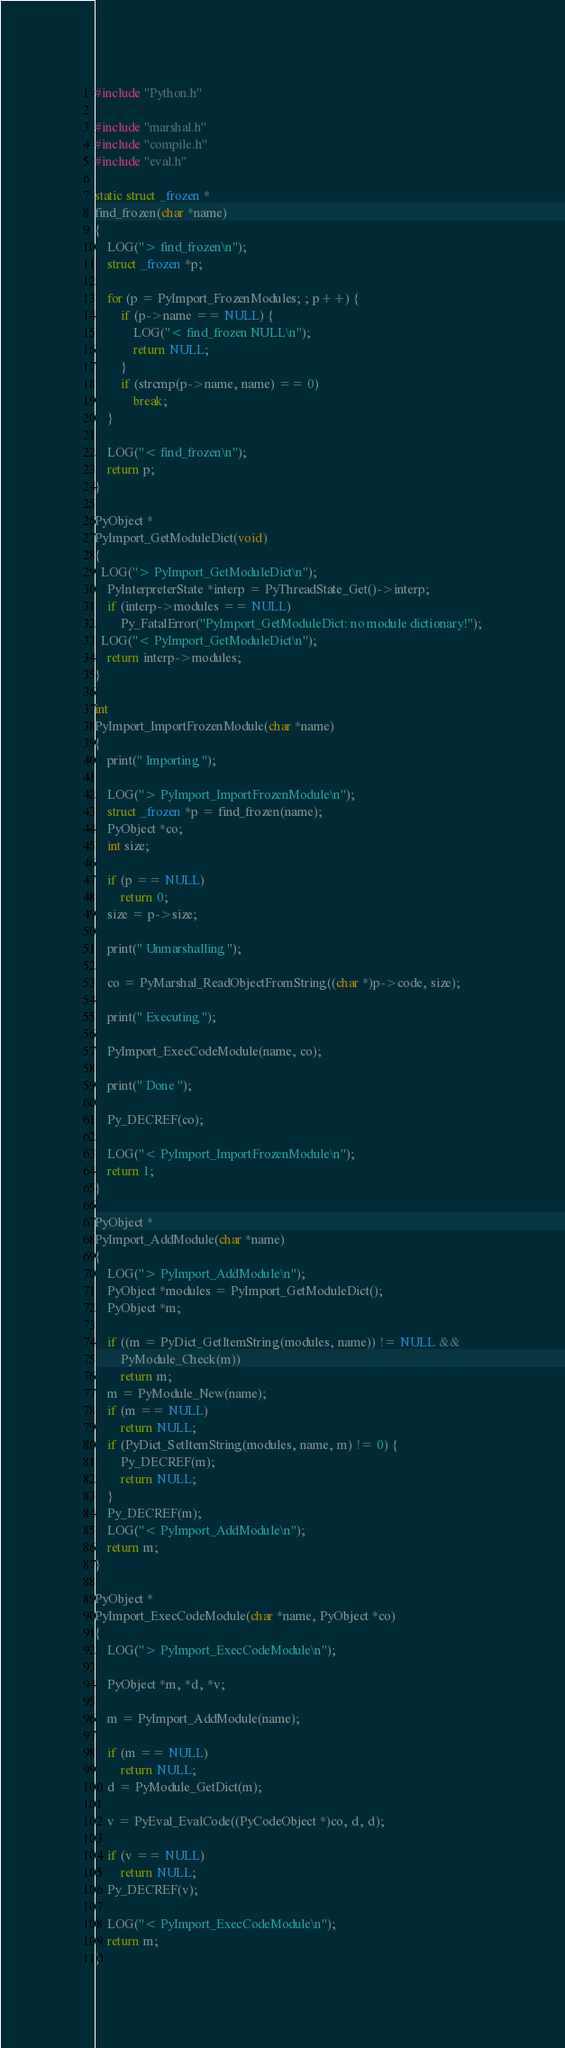Convert code to text. <code><loc_0><loc_0><loc_500><loc_500><_C_>#include "Python.h"

#include "marshal.h"
#include "compile.h"
#include "eval.h"

static struct _frozen *
find_frozen(char *name)
{
	LOG("> find_frozen\n");
	struct _frozen *p;

	for (p = PyImport_FrozenModules; ; p++) {
		if (p->name == NULL) {
			LOG("< find_frozen NULL\n");
			return NULL;
		}
		if (strcmp(p->name, name) == 0)
			break;
	}

	LOG("< find_frozen\n");
	return p;
}

PyObject *
PyImport_GetModuleDict(void)
{
  LOG("> PyImport_GetModuleDict\n");
	PyInterpreterState *interp = PyThreadState_Get()->interp;
	if (interp->modules == NULL)
		Py_FatalError("PyImport_GetModuleDict: no module dictionary!");
  LOG("< PyImport_GetModuleDict\n");
	return interp->modules;
}

int
PyImport_ImportFrozenModule(char *name)
{
	print(" Importing ");
	
	LOG("> PyImport_ImportFrozenModule\n");
	struct _frozen *p = find_frozen(name);
	PyObject *co;
	int size;

	if (p == NULL)
		return 0;
	size = p->size;

	print(" Unmarshalling ");
	
	co = PyMarshal_ReadObjectFromString((char *)p->code, size);

	print(" Executing ");
	
	PyImport_ExecCodeModule(name, co);

	print(" Done ");
	
	Py_DECREF(co);

	LOG("< PyImport_ImportFrozenModule\n");
	return 1;
}

PyObject *
PyImport_AddModule(char *name)
{
	LOG("> PyImport_AddModule\n");
	PyObject *modules = PyImport_GetModuleDict();
	PyObject *m;

	if ((m = PyDict_GetItemString(modules, name)) != NULL &&
	    PyModule_Check(m))
		return m;
	m = PyModule_New(name);
	if (m == NULL)
		return NULL;
	if (PyDict_SetItemString(modules, name, m) != 0) {
		Py_DECREF(m);
		return NULL;
	}
	Py_DECREF(m);
	LOG("< PyImport_AddModule\n");
	return m;
}

PyObject *
PyImport_ExecCodeModule(char *name, PyObject *co)
{
	LOG("> PyImport_ExecCodeModule\n");

	PyObject *m, *d, *v;

	m = PyImport_AddModule(name);

	if (m == NULL)
		return NULL;
	d = PyModule_GetDict(m);

	v = PyEval_EvalCode((PyCodeObject *)co, d, d);

	if (v == NULL)
		return NULL;
	Py_DECREF(v);

	LOG("< PyImport_ExecCodeModule\n");
	return m;
}
</code> 